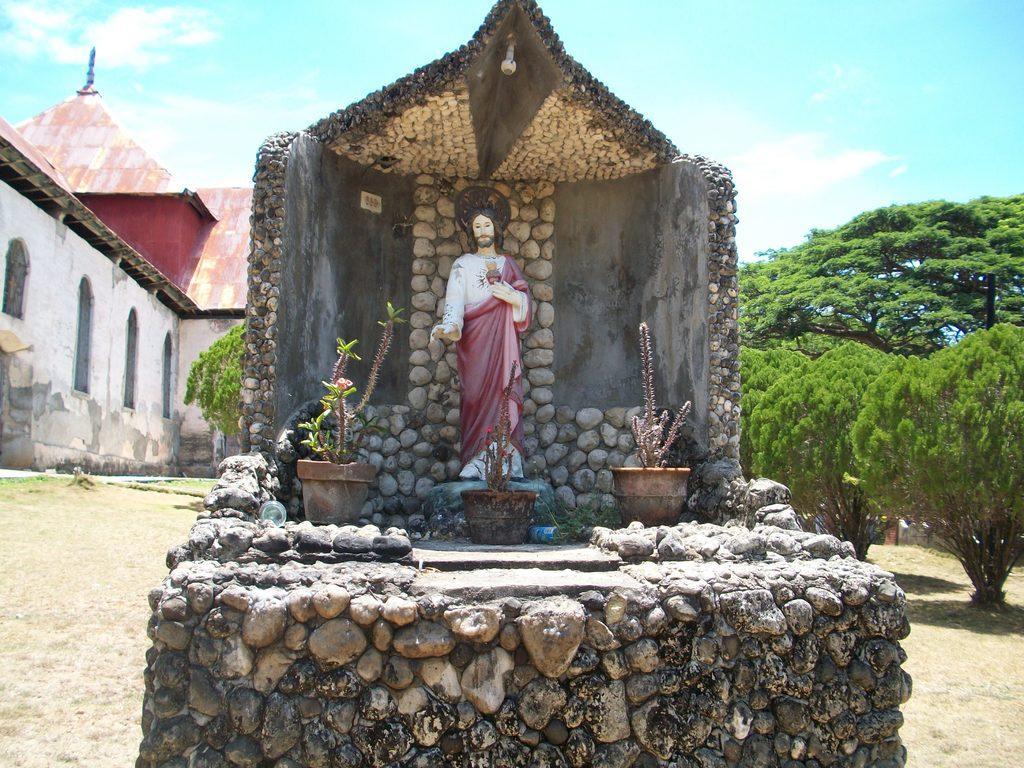Describe this image in one or two sentences. We can see sculpture on stone and we can see house plants. In the background we can see building,trees and sky. 